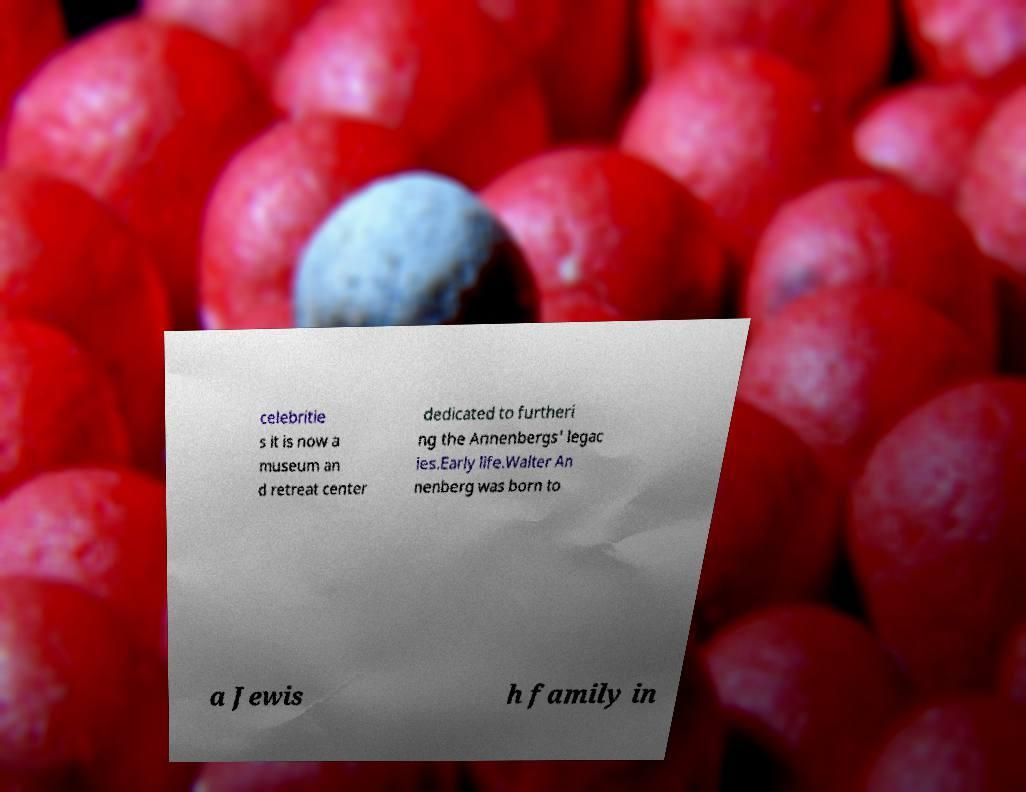There's text embedded in this image that I need extracted. Can you transcribe it verbatim? celebritie s it is now a museum an d retreat center dedicated to furtheri ng the Annenbergs' legac ies.Early life.Walter An nenberg was born to a Jewis h family in 